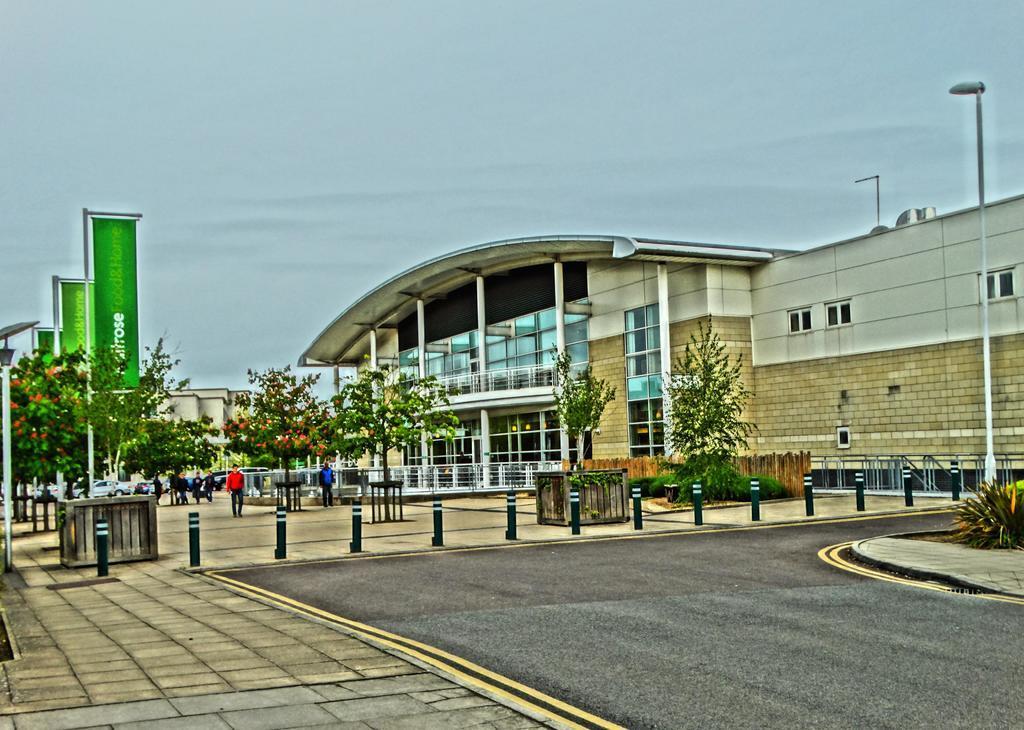Could you give a brief overview of what you see in this image? In this picture I can see group of people standing, there are vehicles, poles, lights, boards, plants, trees, there is a building, and in the background there is sky. 